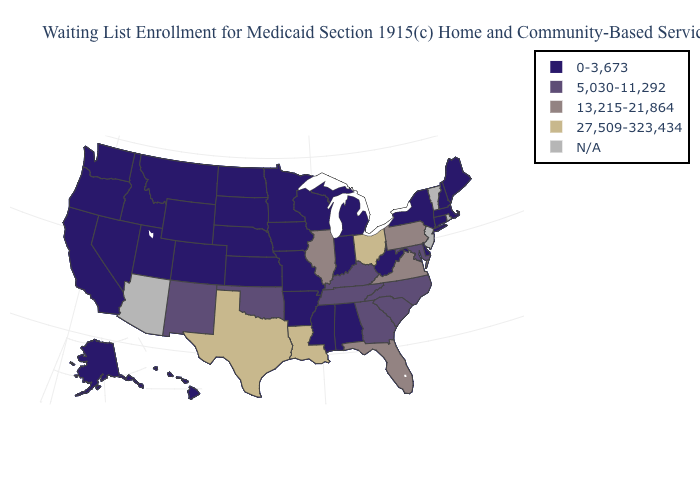Name the states that have a value in the range 5,030-11,292?
Keep it brief. Georgia, Kentucky, Maryland, New Mexico, North Carolina, Oklahoma, South Carolina, Tennessee. How many symbols are there in the legend?
Answer briefly. 5. Does the first symbol in the legend represent the smallest category?
Quick response, please. Yes. What is the highest value in states that border West Virginia?
Concise answer only. 27,509-323,434. What is the value of Connecticut?
Keep it brief. 0-3,673. Is the legend a continuous bar?
Give a very brief answer. No. What is the value of New Hampshire?
Answer briefly. 0-3,673. What is the highest value in the USA?
Write a very short answer. 27,509-323,434. Which states have the lowest value in the USA?
Keep it brief. Alabama, Alaska, Arkansas, California, Colorado, Connecticut, Delaware, Hawaii, Idaho, Indiana, Iowa, Kansas, Maine, Massachusetts, Michigan, Minnesota, Mississippi, Missouri, Montana, Nebraska, Nevada, New Hampshire, New York, North Dakota, Oregon, South Dakota, Utah, Washington, West Virginia, Wisconsin, Wyoming. Name the states that have a value in the range N/A?
Be succinct. Arizona, New Jersey, Rhode Island, Vermont. What is the value of Maryland?
Quick response, please. 5,030-11,292. What is the value of Utah?
Keep it brief. 0-3,673. What is the highest value in states that border Oregon?
Give a very brief answer. 0-3,673. Name the states that have a value in the range 27,509-323,434?
Write a very short answer. Louisiana, Ohio, Texas. What is the value of Maryland?
Concise answer only. 5,030-11,292. 